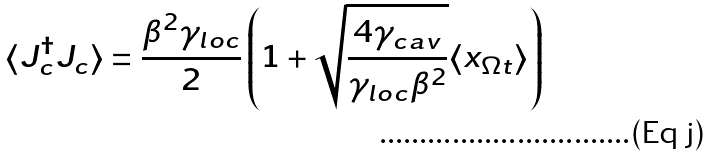Convert formula to latex. <formula><loc_0><loc_0><loc_500><loc_500>\langle J ^ { \dagger } _ { c } J _ { c } \rangle = \frac { \beta ^ { 2 } \gamma _ { l o c } } { 2 } \left ( 1 + \sqrt { \frac { 4 \gamma _ { c a v } } { \gamma _ { l o c } \beta ^ { 2 } } } \langle x _ { \Omega t } \rangle \right )</formula> 